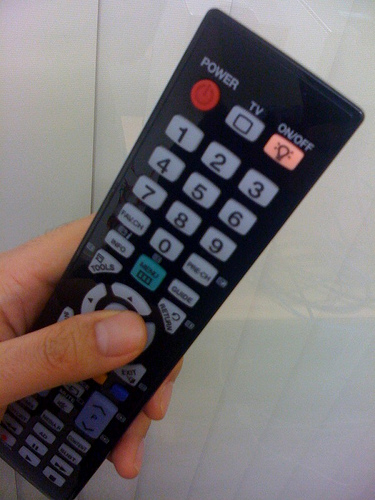<image>Which on isn't used to watch TV? It is unanswerable which one isn't used to watch TV. Which on isn't used to watch TV? I don't know which one isn't used to watch TV. It can be any of them. 